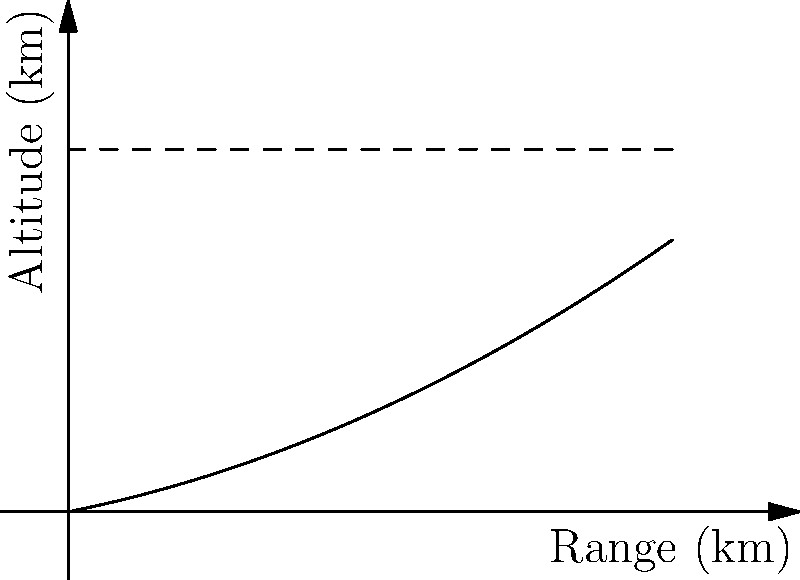Based on the missile trajectory shown in the graph, which depicts a naval missile's flight path, estimate the maximum range of the missile in kilometers. Assume the missile's propulsion system provides an initial velocity of 1000 m/s and its aerodynamic profile results in the parabolic trajectory shown. To estimate the maximum range of the naval missile, we'll follow these steps:

1) From the graph, we can see that the missile's trajectory is approximately parabolic, reaching a maximum altitude of about 300 km.

2) The range is represented by the x-axis, and we can see that the impact point is around 450 km from the launch point.

3) To verify this estimate, we can use the equation for the range of a projectile:

   $R = \frac{v_0^2 \sin(2\theta)}{g}$

   Where:
   $R$ is the range
   $v_0$ is the initial velocity (1000 m/s)
   $\theta$ is the launch angle
   $g$ is the acceleration due to gravity (approximately 9.8 m/s^2)

4) The maximum range occurs at a launch angle of 45°. Substituting these values:

   $R = \frac{(1000 \text{ m/s})^2 \sin(2 \cdot 45°)}{9.8 \text{ m/s}^2}$

5) Simplifying:
   $R = \frac{1,000,000 \cdot 1}{9.8} \approx 102,040 \text{ m} \approx 102 \text{ km}$

6) This calculation assumes a flat Earth and no air resistance, which is unrealistic for long-range missiles. The actual range of 450 km shown in the graph accounts for the missile's propulsion system, which continues to provide thrust after the initial launch, and the curvature of the Earth.

7) Therefore, based on the graph and considering the advanced propulsion system, we can estimate the maximum range of the naval missile to be approximately 450 km.
Answer: 450 km 